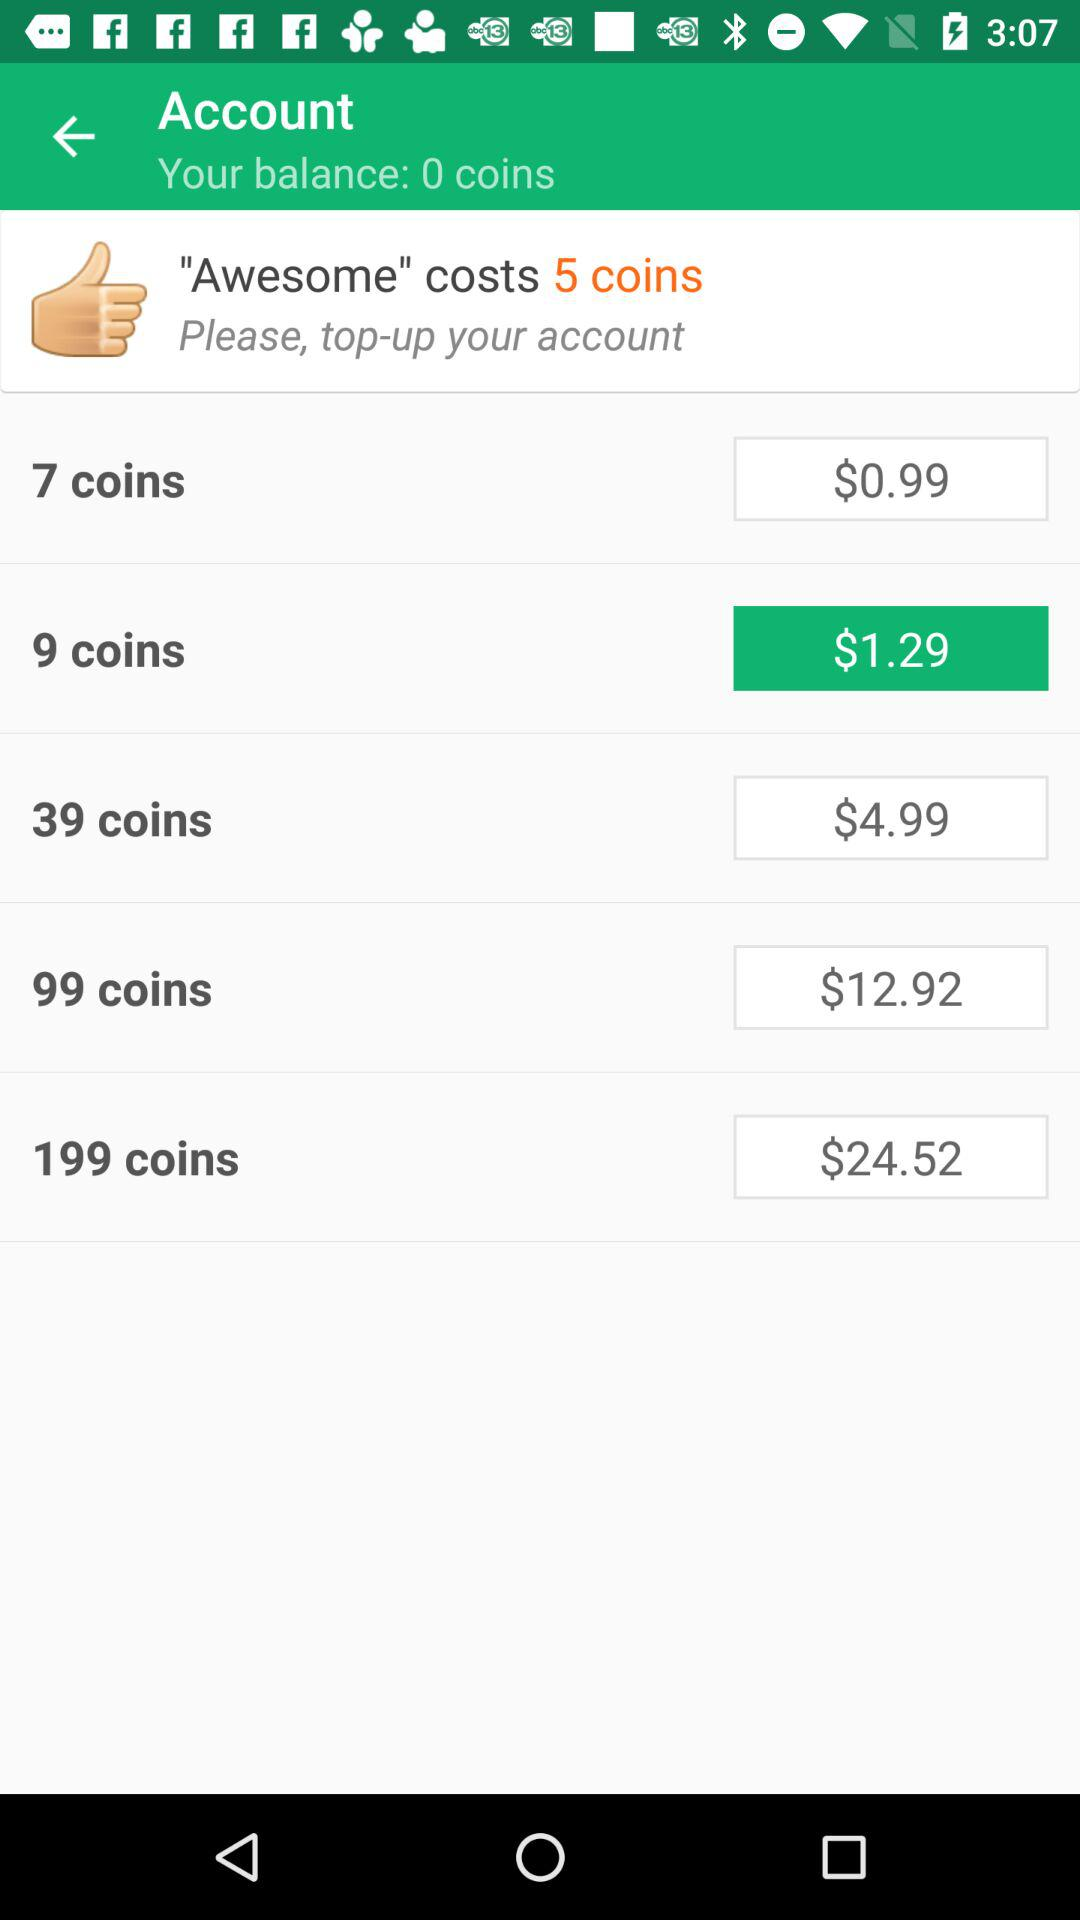How many coins are required to purchase the most expensive item? 199 